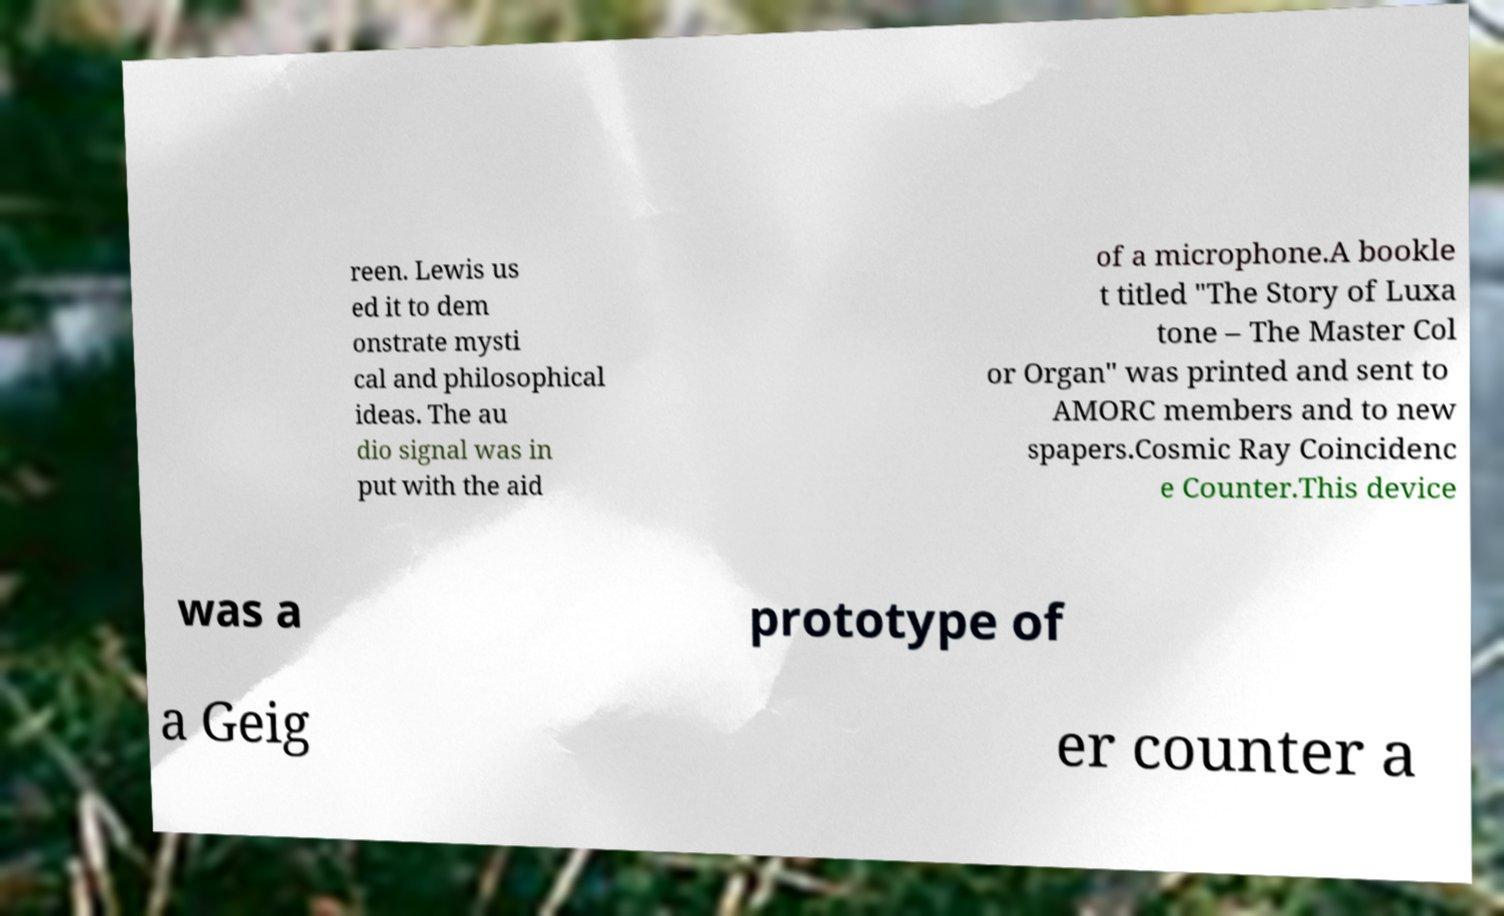There's text embedded in this image that I need extracted. Can you transcribe it verbatim? reen. Lewis us ed it to dem onstrate mysti cal and philosophical ideas. The au dio signal was in put with the aid of a microphone.A bookle t titled "The Story of Luxa tone – The Master Col or Organ" was printed and sent to AMORC members and to new spapers.Cosmic Ray Coincidenc e Counter.This device was a prototype of a Geig er counter a 